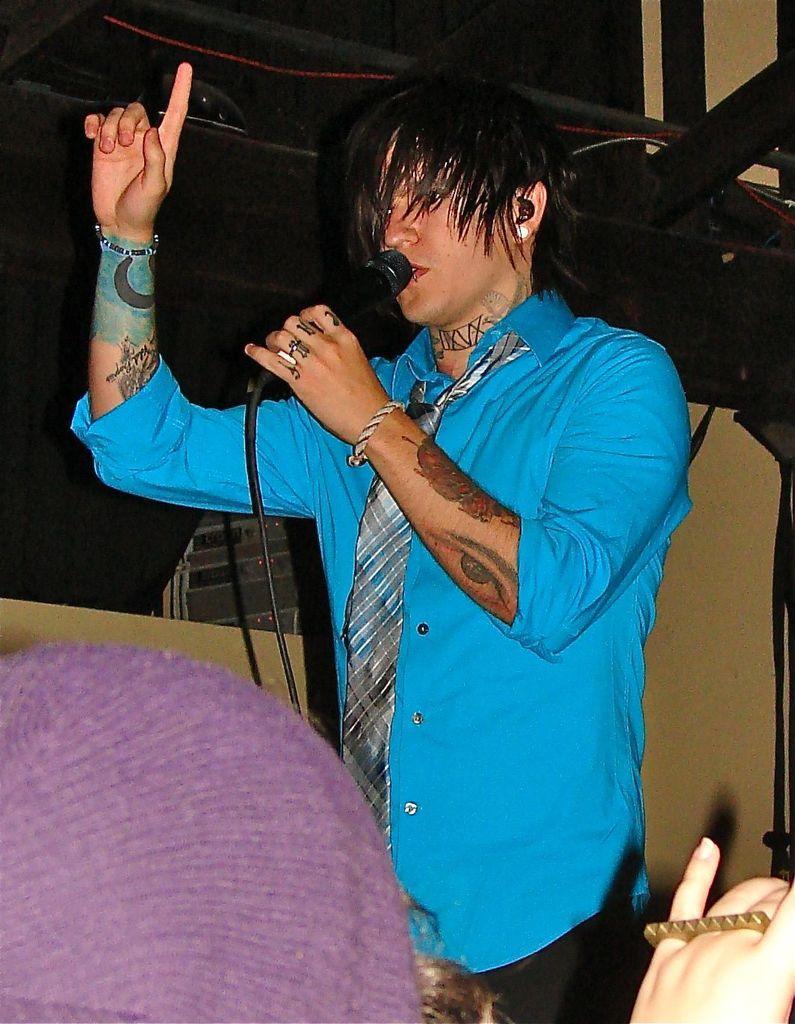Could you give a brief overview of what you see in this image? Bottom of the image a person is sitting. In the middle of the image a person is standing and holding a microphone. Behind the person there is a wall. 